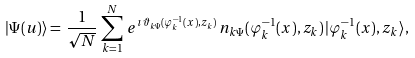Convert formula to latex. <formula><loc_0><loc_0><loc_500><loc_500>| \Psi ( u ) \rangle = \, \frac { 1 } { \sqrt { N } } \, \sum ^ { N } _ { k = 1 } \, e ^ { \imath \, \vartheta _ { k \Psi } ( \varphi ^ { - 1 } _ { k } ( x ) , z _ { k } ) } \, n _ { k \Psi } ( \varphi ^ { - 1 } _ { k } ( x ) , z _ { k } ) \, | \varphi ^ { - 1 } _ { k } ( x ) , z _ { k } \rangle ,</formula> 